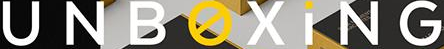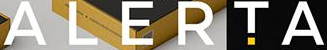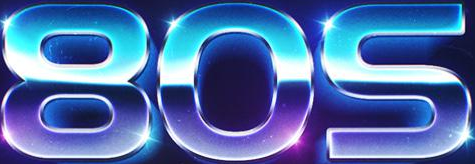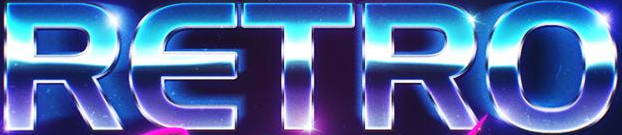Read the text from these images in sequence, separated by a semicolon. UNBOXiNG; ALERTA; 80S; RETRO 